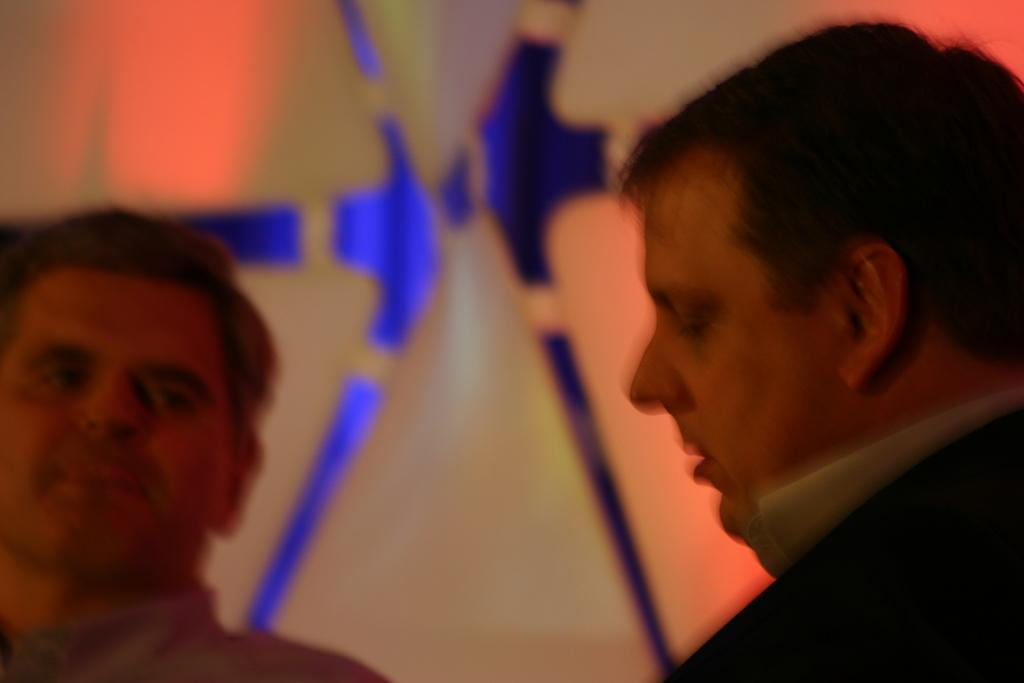How many people are in the image? There are two persons in the image. Can you describe the faces of the people in the image? The faces of the two persons are visible in the image. What is the condition of the background in the image? The background of the image is blurred. Is there a pot in the image? There is no pot present in the image. Does the existence of the two persons in the image prove the existence of extraterrestrial life? The presence of two persons in the image does not prove the existence of extraterrestrial life, as they appear to be human. 